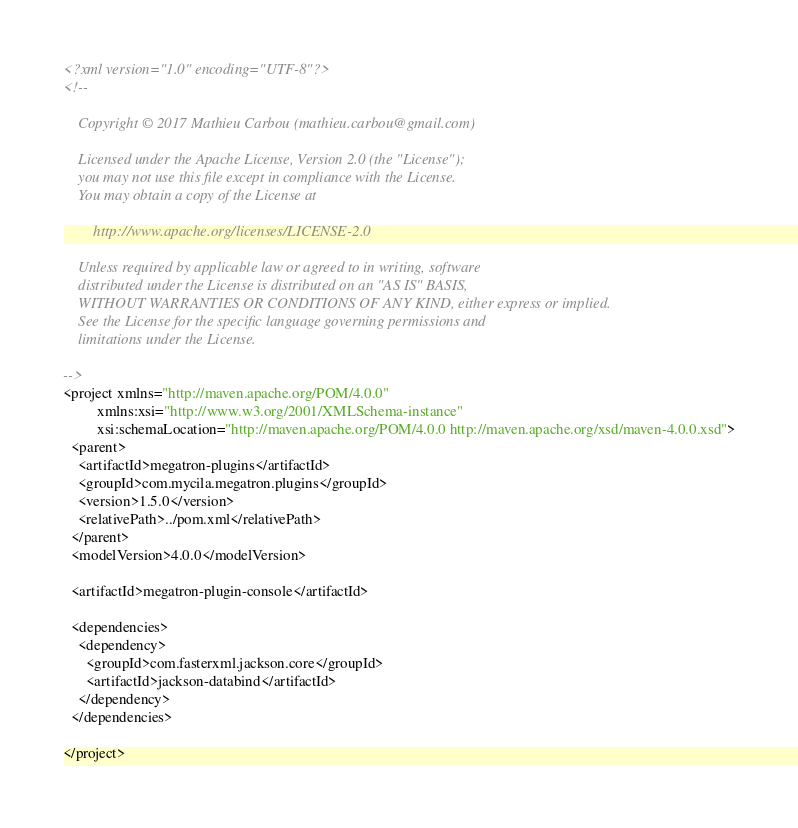<code> <loc_0><loc_0><loc_500><loc_500><_XML_><?xml version="1.0" encoding="UTF-8"?>
<!--

    Copyright © 2017 Mathieu Carbou (mathieu.carbou@gmail.com)

    Licensed under the Apache License, Version 2.0 (the "License");
    you may not use this file except in compliance with the License.
    You may obtain a copy of the License at

        http://www.apache.org/licenses/LICENSE-2.0

    Unless required by applicable law or agreed to in writing, software
    distributed under the License is distributed on an "AS IS" BASIS,
    WITHOUT WARRANTIES OR CONDITIONS OF ANY KIND, either express or implied.
    See the License for the specific language governing permissions and
    limitations under the License.

-->
<project xmlns="http://maven.apache.org/POM/4.0.0"
         xmlns:xsi="http://www.w3.org/2001/XMLSchema-instance"
         xsi:schemaLocation="http://maven.apache.org/POM/4.0.0 http://maven.apache.org/xsd/maven-4.0.0.xsd">
  <parent>
    <artifactId>megatron-plugins</artifactId>
    <groupId>com.mycila.megatron.plugins</groupId>
    <version>1.5.0</version>
    <relativePath>../pom.xml</relativePath>
  </parent>
  <modelVersion>4.0.0</modelVersion>

  <artifactId>megatron-plugin-console</artifactId>

  <dependencies>
    <dependency>
      <groupId>com.fasterxml.jackson.core</groupId>
      <artifactId>jackson-databind</artifactId>
    </dependency>
  </dependencies>

</project></code> 